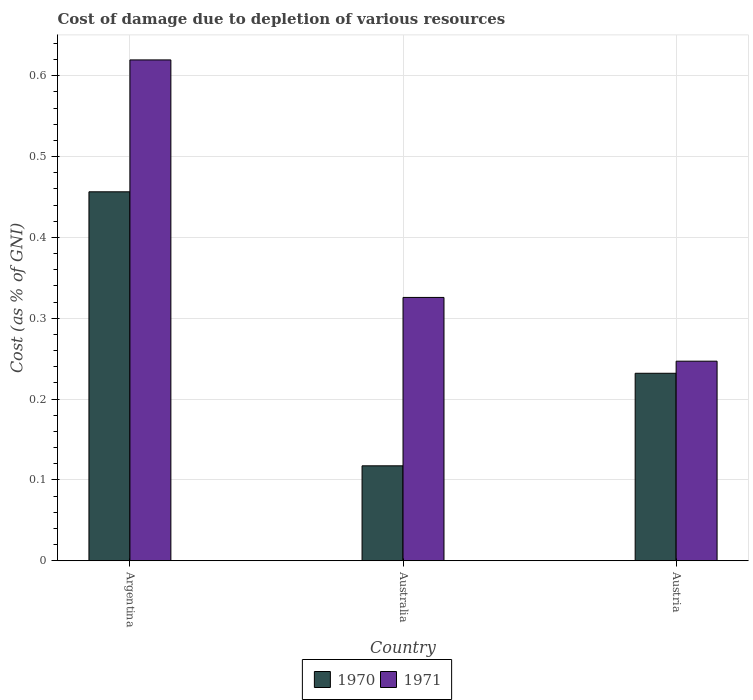How many different coloured bars are there?
Your response must be concise. 2. Are the number of bars per tick equal to the number of legend labels?
Provide a succinct answer. Yes. How many bars are there on the 1st tick from the left?
Offer a terse response. 2. What is the label of the 2nd group of bars from the left?
Your response must be concise. Australia. What is the cost of damage caused due to the depletion of various resources in 1970 in Australia?
Provide a short and direct response. 0.12. Across all countries, what is the maximum cost of damage caused due to the depletion of various resources in 1970?
Make the answer very short. 0.46. Across all countries, what is the minimum cost of damage caused due to the depletion of various resources in 1970?
Keep it short and to the point. 0.12. What is the total cost of damage caused due to the depletion of various resources in 1971 in the graph?
Give a very brief answer. 1.19. What is the difference between the cost of damage caused due to the depletion of various resources in 1970 in Argentina and that in Austria?
Make the answer very short. 0.22. What is the difference between the cost of damage caused due to the depletion of various resources in 1971 in Australia and the cost of damage caused due to the depletion of various resources in 1970 in Austria?
Provide a short and direct response. 0.09. What is the average cost of damage caused due to the depletion of various resources in 1971 per country?
Provide a succinct answer. 0.4. What is the difference between the cost of damage caused due to the depletion of various resources of/in 1971 and cost of damage caused due to the depletion of various resources of/in 1970 in Australia?
Your response must be concise. 0.21. What is the ratio of the cost of damage caused due to the depletion of various resources in 1970 in Australia to that in Austria?
Your answer should be compact. 0.51. Is the cost of damage caused due to the depletion of various resources in 1971 in Argentina less than that in Australia?
Provide a succinct answer. No. Is the difference between the cost of damage caused due to the depletion of various resources in 1971 in Argentina and Australia greater than the difference between the cost of damage caused due to the depletion of various resources in 1970 in Argentina and Australia?
Keep it short and to the point. No. What is the difference between the highest and the second highest cost of damage caused due to the depletion of various resources in 1970?
Provide a succinct answer. 0.34. What is the difference between the highest and the lowest cost of damage caused due to the depletion of various resources in 1970?
Make the answer very short. 0.34. Is the sum of the cost of damage caused due to the depletion of various resources in 1970 in Argentina and Australia greater than the maximum cost of damage caused due to the depletion of various resources in 1971 across all countries?
Offer a terse response. No. Are the values on the major ticks of Y-axis written in scientific E-notation?
Provide a succinct answer. No. How are the legend labels stacked?
Provide a succinct answer. Horizontal. What is the title of the graph?
Your response must be concise. Cost of damage due to depletion of various resources. What is the label or title of the X-axis?
Offer a terse response. Country. What is the label or title of the Y-axis?
Your response must be concise. Cost (as % of GNI). What is the Cost (as % of GNI) of 1970 in Argentina?
Your answer should be compact. 0.46. What is the Cost (as % of GNI) of 1971 in Argentina?
Provide a short and direct response. 0.62. What is the Cost (as % of GNI) in 1970 in Australia?
Offer a terse response. 0.12. What is the Cost (as % of GNI) of 1971 in Australia?
Your answer should be very brief. 0.33. What is the Cost (as % of GNI) in 1970 in Austria?
Your response must be concise. 0.23. What is the Cost (as % of GNI) of 1971 in Austria?
Offer a terse response. 0.25. Across all countries, what is the maximum Cost (as % of GNI) of 1970?
Your answer should be compact. 0.46. Across all countries, what is the maximum Cost (as % of GNI) of 1971?
Offer a very short reply. 0.62. Across all countries, what is the minimum Cost (as % of GNI) of 1970?
Give a very brief answer. 0.12. Across all countries, what is the minimum Cost (as % of GNI) of 1971?
Make the answer very short. 0.25. What is the total Cost (as % of GNI) of 1970 in the graph?
Your answer should be very brief. 0.81. What is the total Cost (as % of GNI) in 1971 in the graph?
Ensure brevity in your answer.  1.19. What is the difference between the Cost (as % of GNI) in 1970 in Argentina and that in Australia?
Give a very brief answer. 0.34. What is the difference between the Cost (as % of GNI) of 1971 in Argentina and that in Australia?
Make the answer very short. 0.29. What is the difference between the Cost (as % of GNI) of 1970 in Argentina and that in Austria?
Give a very brief answer. 0.22. What is the difference between the Cost (as % of GNI) in 1971 in Argentina and that in Austria?
Ensure brevity in your answer.  0.37. What is the difference between the Cost (as % of GNI) of 1970 in Australia and that in Austria?
Make the answer very short. -0.11. What is the difference between the Cost (as % of GNI) of 1971 in Australia and that in Austria?
Keep it short and to the point. 0.08. What is the difference between the Cost (as % of GNI) in 1970 in Argentina and the Cost (as % of GNI) in 1971 in Australia?
Your answer should be very brief. 0.13. What is the difference between the Cost (as % of GNI) in 1970 in Argentina and the Cost (as % of GNI) in 1971 in Austria?
Your response must be concise. 0.21. What is the difference between the Cost (as % of GNI) in 1970 in Australia and the Cost (as % of GNI) in 1971 in Austria?
Your answer should be very brief. -0.13. What is the average Cost (as % of GNI) in 1970 per country?
Keep it short and to the point. 0.27. What is the average Cost (as % of GNI) of 1971 per country?
Provide a succinct answer. 0.4. What is the difference between the Cost (as % of GNI) in 1970 and Cost (as % of GNI) in 1971 in Argentina?
Offer a terse response. -0.16. What is the difference between the Cost (as % of GNI) in 1970 and Cost (as % of GNI) in 1971 in Australia?
Offer a very short reply. -0.21. What is the difference between the Cost (as % of GNI) in 1970 and Cost (as % of GNI) in 1971 in Austria?
Give a very brief answer. -0.01. What is the ratio of the Cost (as % of GNI) of 1970 in Argentina to that in Australia?
Keep it short and to the point. 3.89. What is the ratio of the Cost (as % of GNI) in 1971 in Argentina to that in Australia?
Your response must be concise. 1.9. What is the ratio of the Cost (as % of GNI) in 1970 in Argentina to that in Austria?
Your response must be concise. 1.97. What is the ratio of the Cost (as % of GNI) in 1971 in Argentina to that in Austria?
Provide a short and direct response. 2.51. What is the ratio of the Cost (as % of GNI) of 1970 in Australia to that in Austria?
Provide a short and direct response. 0.51. What is the ratio of the Cost (as % of GNI) of 1971 in Australia to that in Austria?
Your answer should be compact. 1.32. What is the difference between the highest and the second highest Cost (as % of GNI) in 1970?
Your answer should be compact. 0.22. What is the difference between the highest and the second highest Cost (as % of GNI) in 1971?
Ensure brevity in your answer.  0.29. What is the difference between the highest and the lowest Cost (as % of GNI) of 1970?
Your response must be concise. 0.34. What is the difference between the highest and the lowest Cost (as % of GNI) of 1971?
Offer a terse response. 0.37. 